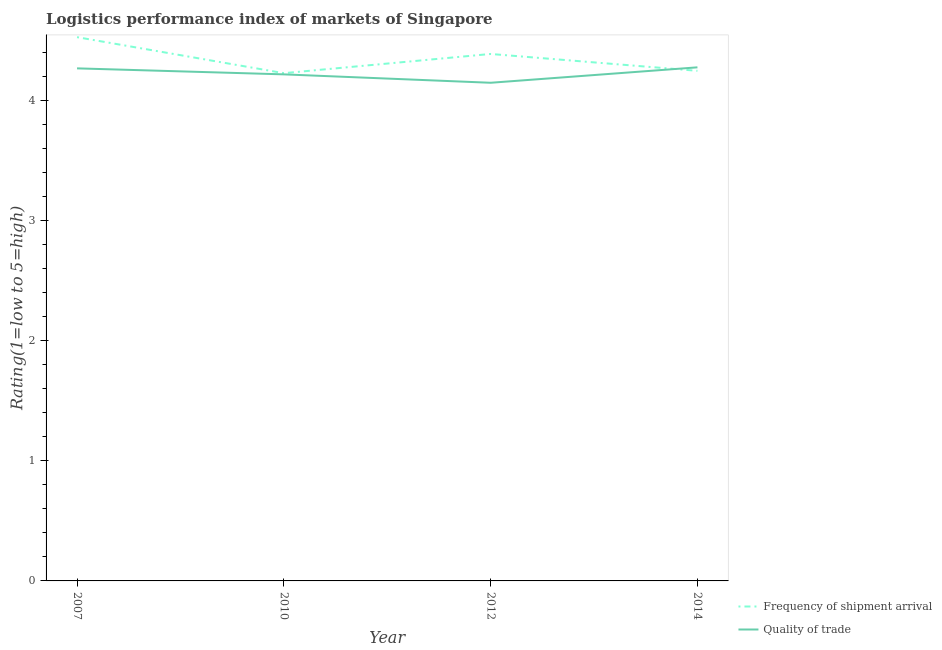What is the lpi of frequency of shipment arrival in 2012?
Your answer should be compact. 4.39. Across all years, what is the maximum lpi quality of trade?
Ensure brevity in your answer.  4.28. Across all years, what is the minimum lpi quality of trade?
Offer a terse response. 4.15. In which year was the lpi quality of trade minimum?
Your answer should be very brief. 2012. What is the total lpi quality of trade in the graph?
Offer a very short reply. 16.92. What is the difference between the lpi of frequency of shipment arrival in 2010 and that in 2012?
Make the answer very short. -0.16. What is the difference between the lpi quality of trade in 2007 and the lpi of frequency of shipment arrival in 2010?
Provide a short and direct response. 0.04. What is the average lpi of frequency of shipment arrival per year?
Your answer should be compact. 4.35. In the year 2010, what is the difference between the lpi of frequency of shipment arrival and lpi quality of trade?
Ensure brevity in your answer.  0.01. In how many years, is the lpi of frequency of shipment arrival greater than 3?
Provide a short and direct response. 4. What is the ratio of the lpi of frequency of shipment arrival in 2010 to that in 2014?
Offer a terse response. 1. Is the lpi quality of trade in 2010 less than that in 2014?
Your answer should be compact. Yes. Is the difference between the lpi quality of trade in 2012 and 2014 greater than the difference between the lpi of frequency of shipment arrival in 2012 and 2014?
Ensure brevity in your answer.  No. What is the difference between the highest and the second highest lpi of frequency of shipment arrival?
Offer a very short reply. 0.14. What is the difference between the highest and the lowest lpi quality of trade?
Provide a short and direct response. 0.13. In how many years, is the lpi quality of trade greater than the average lpi quality of trade taken over all years?
Offer a terse response. 2. Is the sum of the lpi quality of trade in 2012 and 2014 greater than the maximum lpi of frequency of shipment arrival across all years?
Offer a very short reply. Yes. Does the lpi quality of trade monotonically increase over the years?
Your answer should be very brief. No. Is the lpi quality of trade strictly less than the lpi of frequency of shipment arrival over the years?
Keep it short and to the point. No. How many lines are there?
Your response must be concise. 2. How many years are there in the graph?
Provide a succinct answer. 4. What is the difference between two consecutive major ticks on the Y-axis?
Your answer should be very brief. 1. Does the graph contain any zero values?
Your answer should be compact. No. How many legend labels are there?
Provide a succinct answer. 2. What is the title of the graph?
Your answer should be compact. Logistics performance index of markets of Singapore. Does "Under-5(female)" appear as one of the legend labels in the graph?
Your answer should be compact. No. What is the label or title of the Y-axis?
Your answer should be compact. Rating(1=low to 5=high). What is the Rating(1=low to 5=high) of Frequency of shipment arrival in 2007?
Ensure brevity in your answer.  4.53. What is the Rating(1=low to 5=high) of Quality of trade in 2007?
Offer a terse response. 4.27. What is the Rating(1=low to 5=high) of Frequency of shipment arrival in 2010?
Make the answer very short. 4.23. What is the Rating(1=low to 5=high) of Quality of trade in 2010?
Make the answer very short. 4.22. What is the Rating(1=low to 5=high) in Frequency of shipment arrival in 2012?
Give a very brief answer. 4.39. What is the Rating(1=low to 5=high) of Quality of trade in 2012?
Ensure brevity in your answer.  4.15. What is the Rating(1=low to 5=high) in Frequency of shipment arrival in 2014?
Provide a succinct answer. 4.25. What is the Rating(1=low to 5=high) in Quality of trade in 2014?
Provide a short and direct response. 4.28. Across all years, what is the maximum Rating(1=low to 5=high) of Frequency of shipment arrival?
Your answer should be compact. 4.53. Across all years, what is the maximum Rating(1=low to 5=high) in Quality of trade?
Your answer should be very brief. 4.28. Across all years, what is the minimum Rating(1=low to 5=high) in Frequency of shipment arrival?
Give a very brief answer. 4.23. Across all years, what is the minimum Rating(1=low to 5=high) in Quality of trade?
Keep it short and to the point. 4.15. What is the total Rating(1=low to 5=high) of Frequency of shipment arrival in the graph?
Provide a short and direct response. 17.4. What is the total Rating(1=low to 5=high) of Quality of trade in the graph?
Give a very brief answer. 16.92. What is the difference between the Rating(1=low to 5=high) of Quality of trade in 2007 and that in 2010?
Provide a short and direct response. 0.05. What is the difference between the Rating(1=low to 5=high) of Frequency of shipment arrival in 2007 and that in 2012?
Provide a succinct answer. 0.14. What is the difference between the Rating(1=low to 5=high) in Quality of trade in 2007 and that in 2012?
Your answer should be very brief. 0.12. What is the difference between the Rating(1=low to 5=high) in Frequency of shipment arrival in 2007 and that in 2014?
Make the answer very short. 0.28. What is the difference between the Rating(1=low to 5=high) in Quality of trade in 2007 and that in 2014?
Give a very brief answer. -0.01. What is the difference between the Rating(1=low to 5=high) in Frequency of shipment arrival in 2010 and that in 2012?
Keep it short and to the point. -0.16. What is the difference between the Rating(1=low to 5=high) in Quality of trade in 2010 and that in 2012?
Your answer should be compact. 0.07. What is the difference between the Rating(1=low to 5=high) in Frequency of shipment arrival in 2010 and that in 2014?
Give a very brief answer. -0.02. What is the difference between the Rating(1=low to 5=high) in Quality of trade in 2010 and that in 2014?
Offer a very short reply. -0.06. What is the difference between the Rating(1=low to 5=high) in Frequency of shipment arrival in 2012 and that in 2014?
Your answer should be very brief. 0.14. What is the difference between the Rating(1=low to 5=high) of Quality of trade in 2012 and that in 2014?
Your response must be concise. -0.13. What is the difference between the Rating(1=low to 5=high) in Frequency of shipment arrival in 2007 and the Rating(1=low to 5=high) in Quality of trade in 2010?
Give a very brief answer. 0.31. What is the difference between the Rating(1=low to 5=high) of Frequency of shipment arrival in 2007 and the Rating(1=low to 5=high) of Quality of trade in 2012?
Keep it short and to the point. 0.38. What is the difference between the Rating(1=low to 5=high) of Frequency of shipment arrival in 2007 and the Rating(1=low to 5=high) of Quality of trade in 2014?
Your answer should be very brief. 0.25. What is the difference between the Rating(1=low to 5=high) in Frequency of shipment arrival in 2010 and the Rating(1=low to 5=high) in Quality of trade in 2012?
Your answer should be compact. 0.08. What is the difference between the Rating(1=low to 5=high) of Frequency of shipment arrival in 2010 and the Rating(1=low to 5=high) of Quality of trade in 2014?
Your answer should be compact. -0.05. What is the difference between the Rating(1=low to 5=high) in Frequency of shipment arrival in 2012 and the Rating(1=low to 5=high) in Quality of trade in 2014?
Offer a very short reply. 0.11. What is the average Rating(1=low to 5=high) of Frequency of shipment arrival per year?
Your response must be concise. 4.35. What is the average Rating(1=low to 5=high) of Quality of trade per year?
Your answer should be compact. 4.23. In the year 2007, what is the difference between the Rating(1=low to 5=high) in Frequency of shipment arrival and Rating(1=low to 5=high) in Quality of trade?
Offer a terse response. 0.26. In the year 2010, what is the difference between the Rating(1=low to 5=high) in Frequency of shipment arrival and Rating(1=low to 5=high) in Quality of trade?
Make the answer very short. 0.01. In the year 2012, what is the difference between the Rating(1=low to 5=high) of Frequency of shipment arrival and Rating(1=low to 5=high) of Quality of trade?
Keep it short and to the point. 0.24. In the year 2014, what is the difference between the Rating(1=low to 5=high) in Frequency of shipment arrival and Rating(1=low to 5=high) in Quality of trade?
Provide a short and direct response. -0.03. What is the ratio of the Rating(1=low to 5=high) in Frequency of shipment arrival in 2007 to that in 2010?
Offer a very short reply. 1.07. What is the ratio of the Rating(1=low to 5=high) in Quality of trade in 2007 to that in 2010?
Offer a terse response. 1.01. What is the ratio of the Rating(1=low to 5=high) in Frequency of shipment arrival in 2007 to that in 2012?
Ensure brevity in your answer.  1.03. What is the ratio of the Rating(1=low to 5=high) in Quality of trade in 2007 to that in 2012?
Provide a short and direct response. 1.03. What is the ratio of the Rating(1=low to 5=high) of Frequency of shipment arrival in 2007 to that in 2014?
Your answer should be compact. 1.07. What is the ratio of the Rating(1=low to 5=high) in Quality of trade in 2007 to that in 2014?
Provide a succinct answer. 1. What is the ratio of the Rating(1=low to 5=high) in Frequency of shipment arrival in 2010 to that in 2012?
Your answer should be very brief. 0.96. What is the ratio of the Rating(1=low to 5=high) of Quality of trade in 2010 to that in 2012?
Your answer should be compact. 1.02. What is the ratio of the Rating(1=low to 5=high) in Frequency of shipment arrival in 2010 to that in 2014?
Provide a short and direct response. 1. What is the ratio of the Rating(1=low to 5=high) of Quality of trade in 2010 to that in 2014?
Your answer should be very brief. 0.99. What is the ratio of the Rating(1=low to 5=high) in Frequency of shipment arrival in 2012 to that in 2014?
Give a very brief answer. 1.03. What is the ratio of the Rating(1=low to 5=high) of Quality of trade in 2012 to that in 2014?
Provide a succinct answer. 0.97. What is the difference between the highest and the second highest Rating(1=low to 5=high) of Frequency of shipment arrival?
Keep it short and to the point. 0.14. What is the difference between the highest and the second highest Rating(1=low to 5=high) of Quality of trade?
Provide a short and direct response. 0.01. What is the difference between the highest and the lowest Rating(1=low to 5=high) in Frequency of shipment arrival?
Keep it short and to the point. 0.3. What is the difference between the highest and the lowest Rating(1=low to 5=high) in Quality of trade?
Your response must be concise. 0.13. 